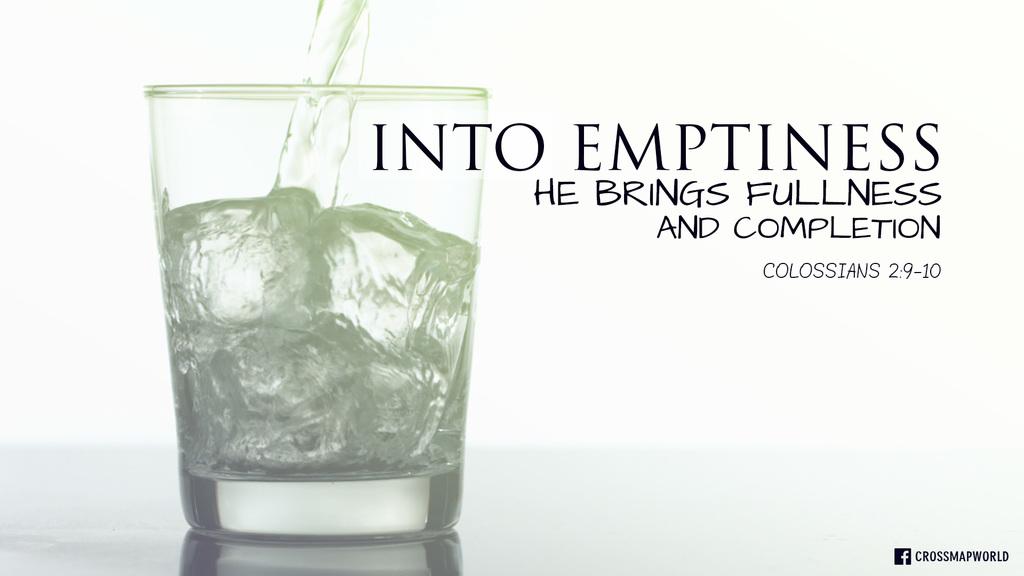What verse is this?
Offer a very short reply. Colossians 2:9-10. What is the word top right of the passage?
Provide a succinct answer. Emptiness. 